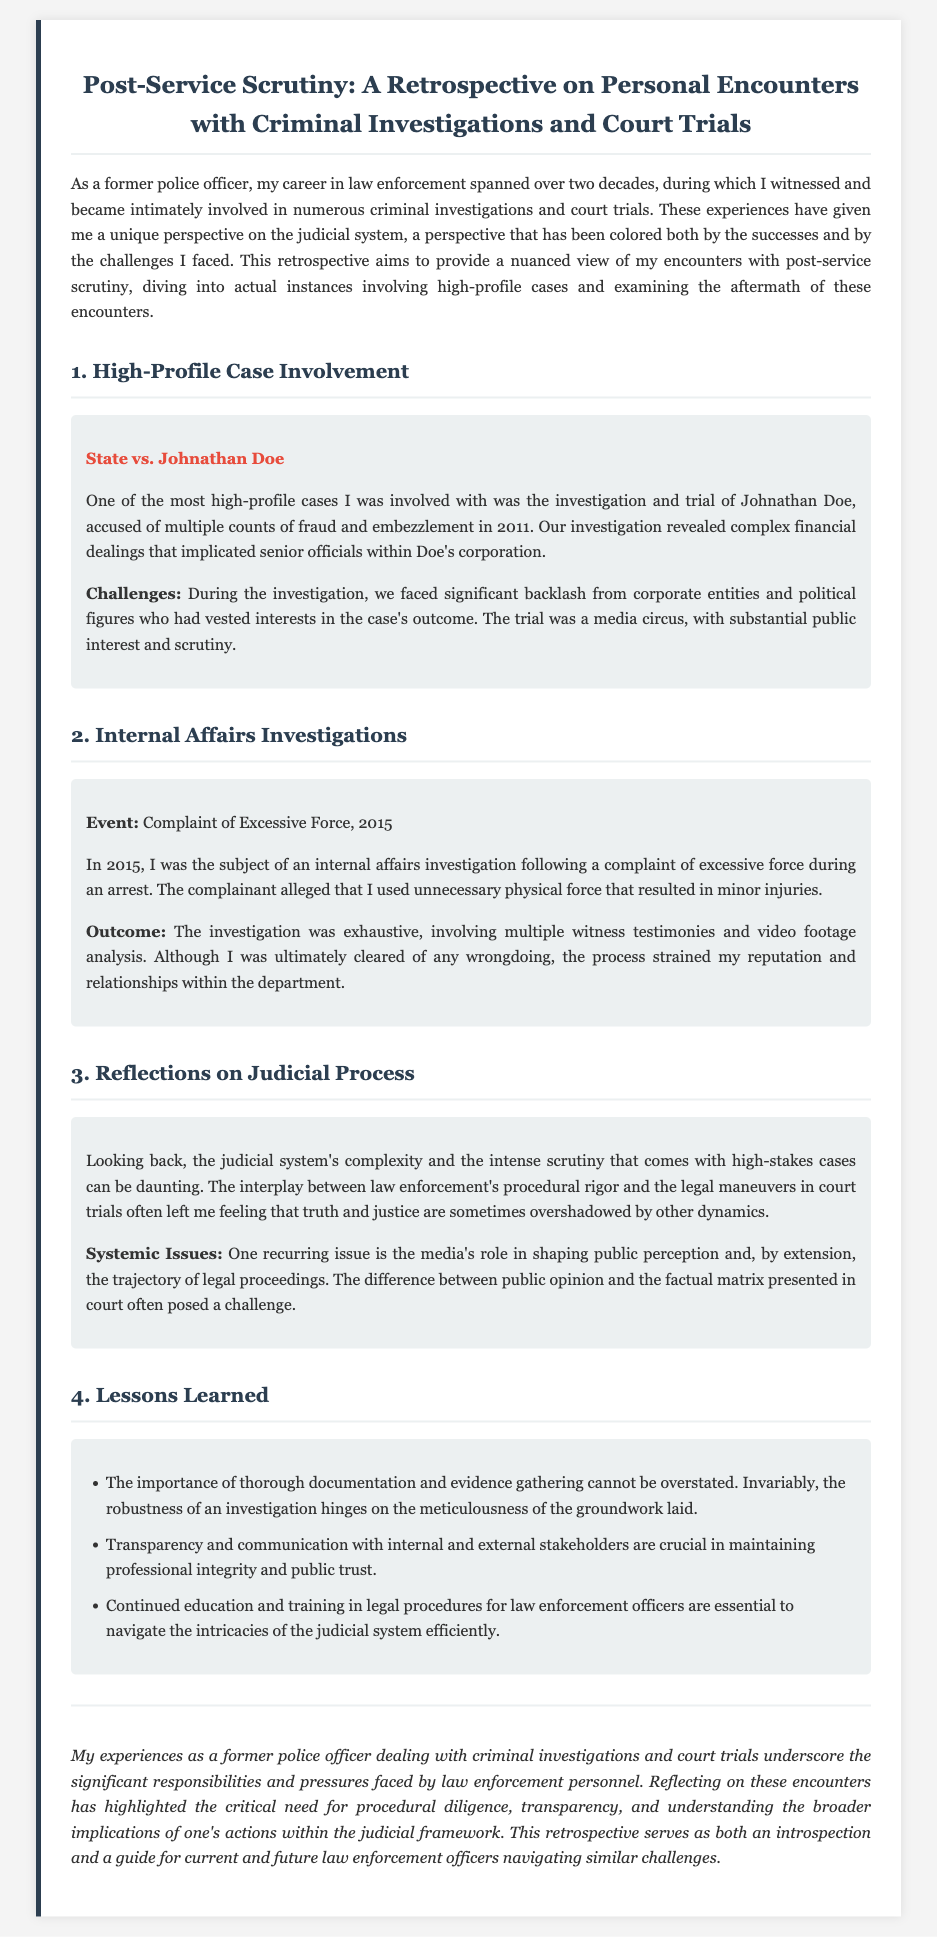What is the title of the document? The title is clearly stated at the beginning of the document, summarizing its main topic.
Answer: Post-Service Scrutiny: A Retrospective on Personal Encounters with Criminal Investigations and Court Trials In what year did the investigation of Johnathan Doe occur? The year of the investigation is specified in the section discussing the high-profile case.
Answer: 2011 What was the complaint against the former police officer in 2015? The document details the specific complaint made, highlighting the nature of the issue.
Answer: Excessive Force How many lessons learned are mentioned in the document? The lessons section contains a specific numbered list detailing the lessons learned.
Answer: Three What was the outcome of the internal affairs investigation? The outcome is stated in the context of the investigation following the complaint.
Answer: Cleared of any wrongdoing What does the author suggest is crucial for maintaining public trust? The author emphasizes specific actions that contribute to professional integrity and public trust.
Answer: Transparency and communication What type of media influence is discussed in the document? The issues related to media influence are addressed in the reflections on the judicial process.
Answer: Shaping public perception What does the author reflect on regarding the judicial system? The author's reflections include a general sentiment about encounters with the judicial system.
Answer: Complexity and scrutiny 